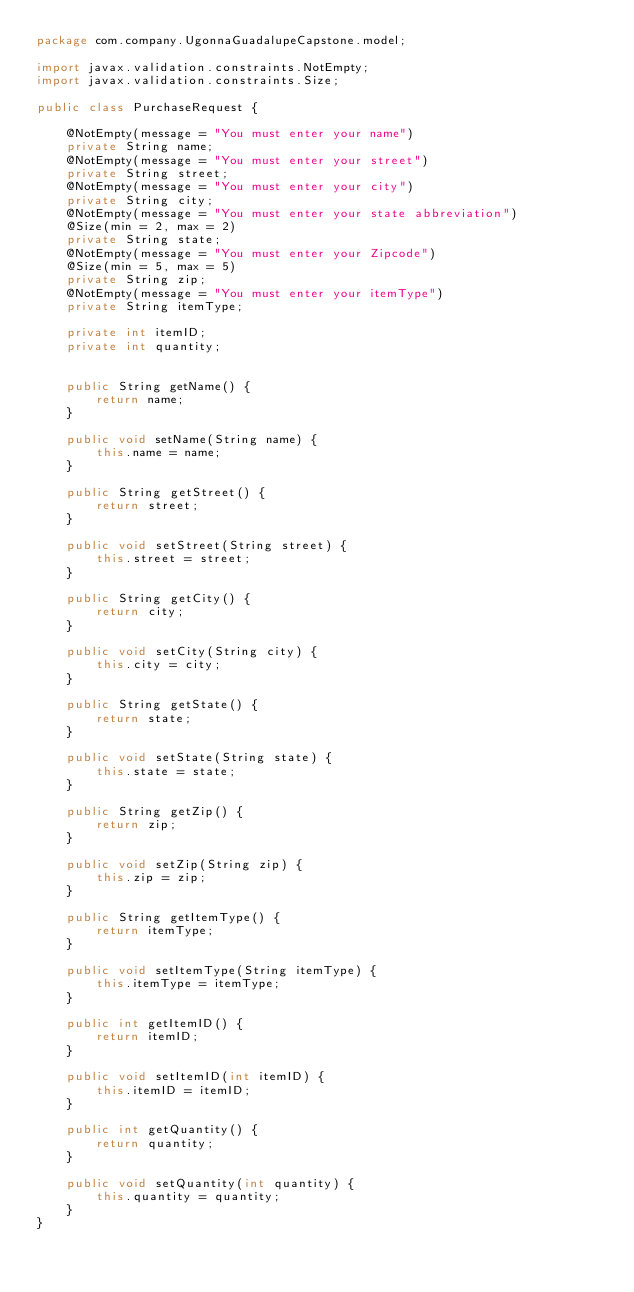Convert code to text. <code><loc_0><loc_0><loc_500><loc_500><_Java_>package com.company.UgonnaGuadalupeCapstone.model;

import javax.validation.constraints.NotEmpty;
import javax.validation.constraints.Size;

public class PurchaseRequest {

    @NotEmpty(message = "You must enter your name")
    private String name;
    @NotEmpty(message = "You must enter your street")
    private String street;
    @NotEmpty(message = "You must enter your city")
    private String city;
    @NotEmpty(message = "You must enter your state abbreviation")
    @Size(min = 2, max = 2)
    private String state;
    @NotEmpty(message = "You must enter your Zipcode")
    @Size(min = 5, max = 5)
    private String zip;
    @NotEmpty(message = "You must enter your itemType")
    private String itemType;

    private int itemID;
    private int quantity;


    public String getName() {
        return name;
    }

    public void setName(String name) {
        this.name = name;
    }

    public String getStreet() {
        return street;
    }

    public void setStreet(String street) {
        this.street = street;
    }

    public String getCity() {
        return city;
    }

    public void setCity(String city) {
        this.city = city;
    }

    public String getState() {
        return state;
    }

    public void setState(String state) {
        this.state = state;
    }

    public String getZip() {
        return zip;
    }

    public void setZip(String zip) {
        this.zip = zip;
    }

    public String getItemType() {
        return itemType;
    }

    public void setItemType(String itemType) {
        this.itemType = itemType;
    }

    public int getItemID() {
        return itemID;
    }

    public void setItemID(int itemID) {
        this.itemID = itemID;
    }

    public int getQuantity() {
        return quantity;
    }

    public void setQuantity(int quantity) {
        this.quantity = quantity;
    }
}
</code> 